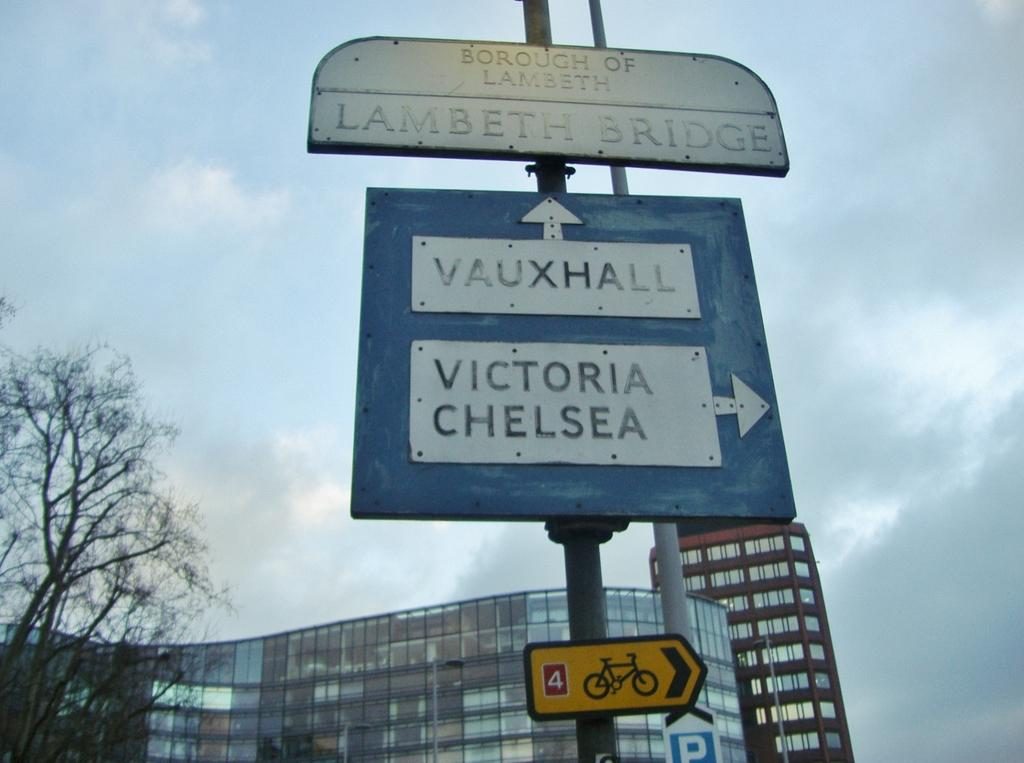Provide a one-sentence caption for the provided image. The sign gives people guidance on which way to Vauxhall and Victoria Chelsea. 